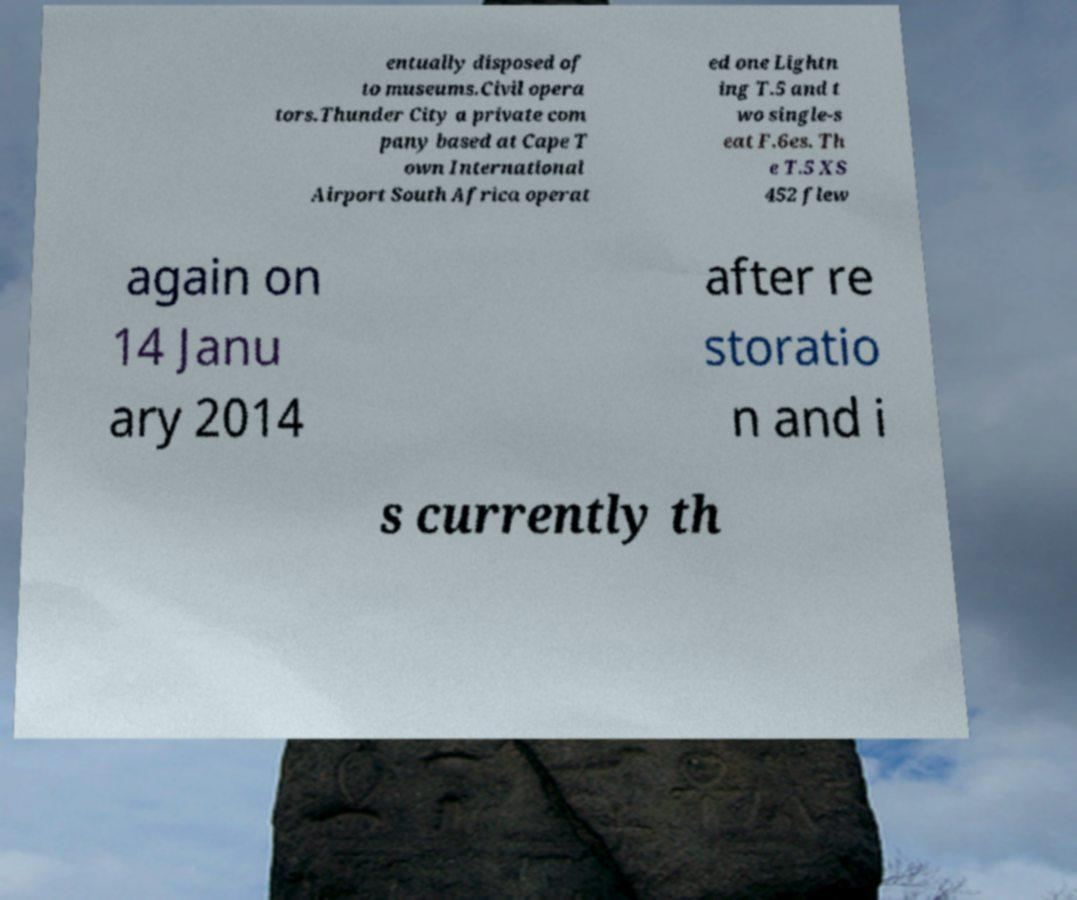Please read and relay the text visible in this image. What does it say? entually disposed of to museums.Civil opera tors.Thunder City a private com pany based at Cape T own International Airport South Africa operat ed one Lightn ing T.5 and t wo single-s eat F.6es. Th e T.5 XS 452 flew again on 14 Janu ary 2014 after re storatio n and i s currently th 